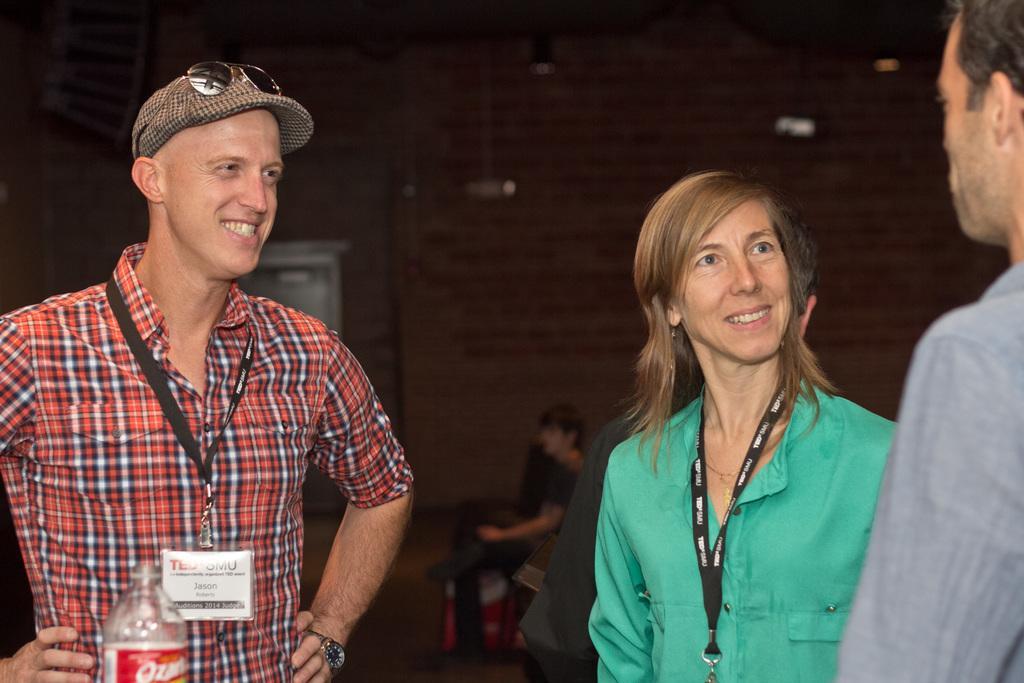Can you describe this image briefly? This is the man and woman standing and smiling. On the right side of the image, I can see another person standing. In the background, I think this is a wall. Here is a person sitting. At the bottom of the image, that looks like a bottle. 